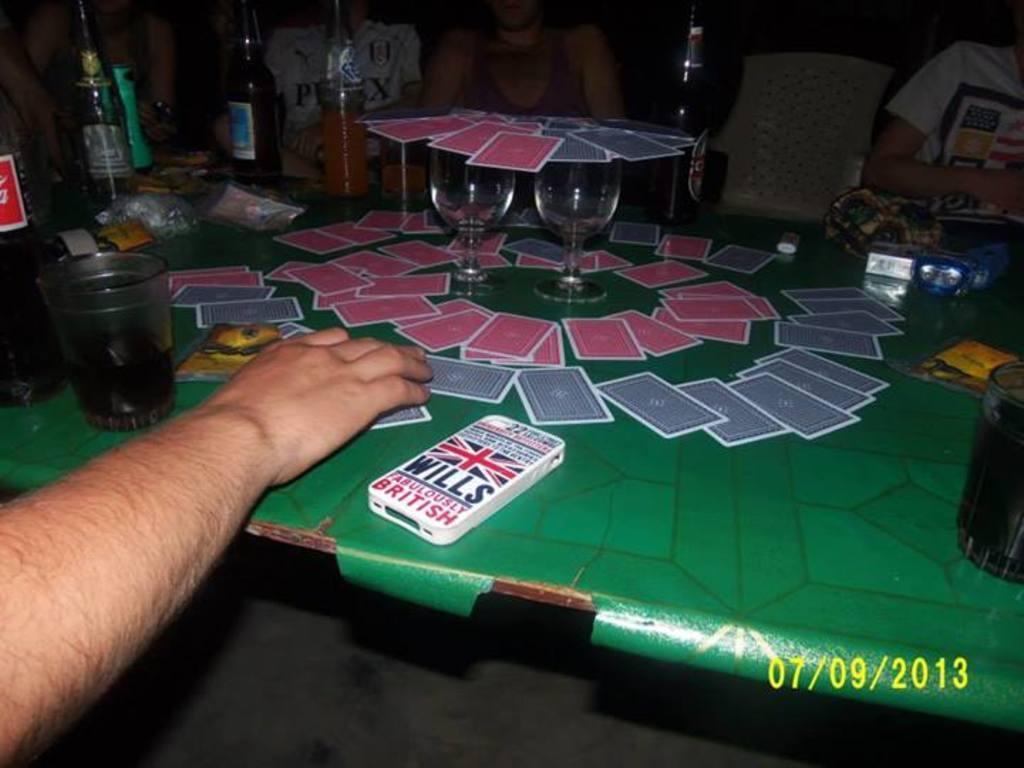Please provide a concise description of this image. As we can see in the image there is a human hand, a table. On table there are cards, glasses and bottles. 